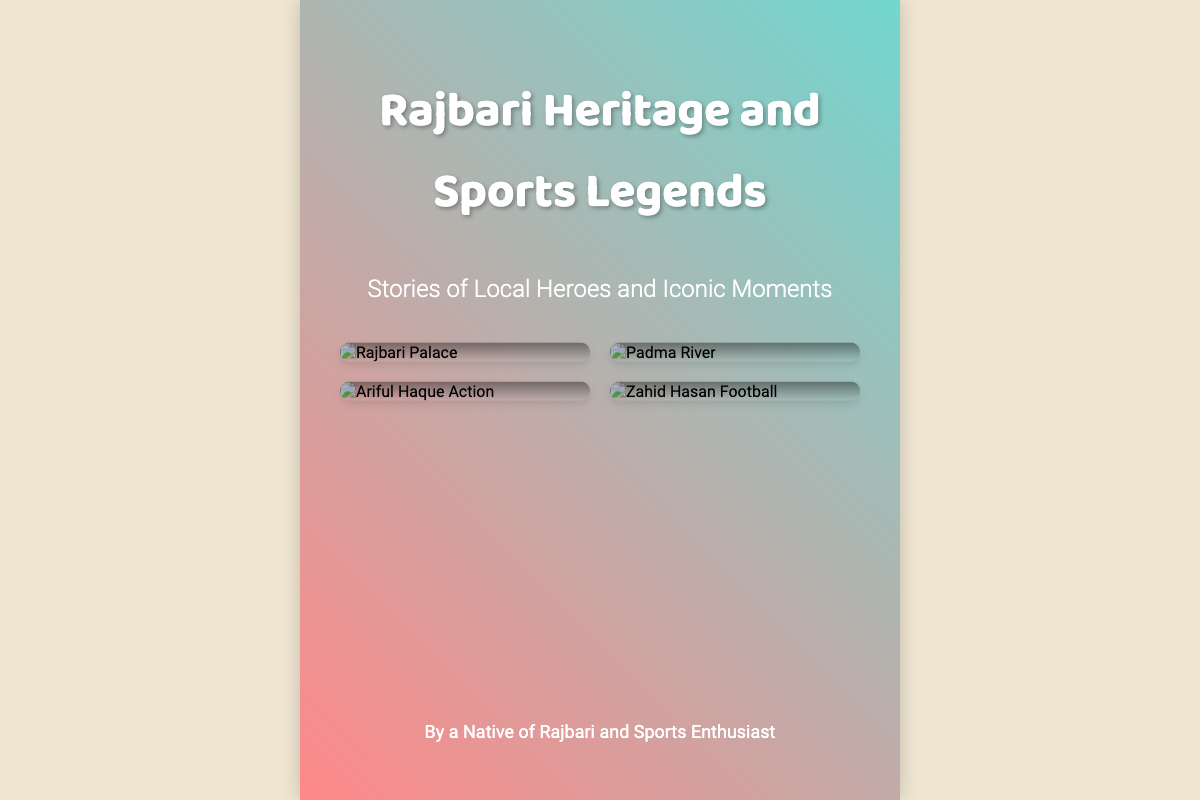what is the title of the book? The title is prominently displayed at the top of the cover.
Answer: Rajbari Heritage and Sports Legends what is the subtitle of the book? The subtitle is located just below the title on the cover.
Answer: Stories of Local Heroes and Iconic Moments how many images are present on the cover? The number of images can be counted in the image grid section of the cover.
Answer: 4 who is the author of the book? The author’s name is listed at the bottom of the content section.
Answer: A Native of Rajbari and Sports Enthusiast what type of imagery is used on the cover besides landmarks? The cover features a combination of images showcasing dynamic action shots related to sports.
Answer: Action shots how is the background of the book cover described? The background is visually described in terms of color and design elements used.
Answer: Gradient and vibrant what design element provides depth to the image containers? The image containers are enhanced with a specific visual feature that adds to their appearance.
Answer: Box shadow what can be inferred about the focus of the book? The elements in the title and images reflect a central theme present throughout the book.
Answer: Rajbari sports history 